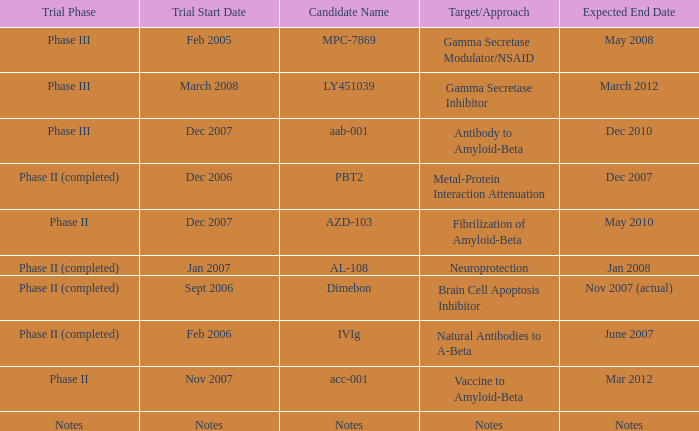What is Candidate Name, when Target/Approach is "vaccine to amyloid-beta"? Acc-001. 